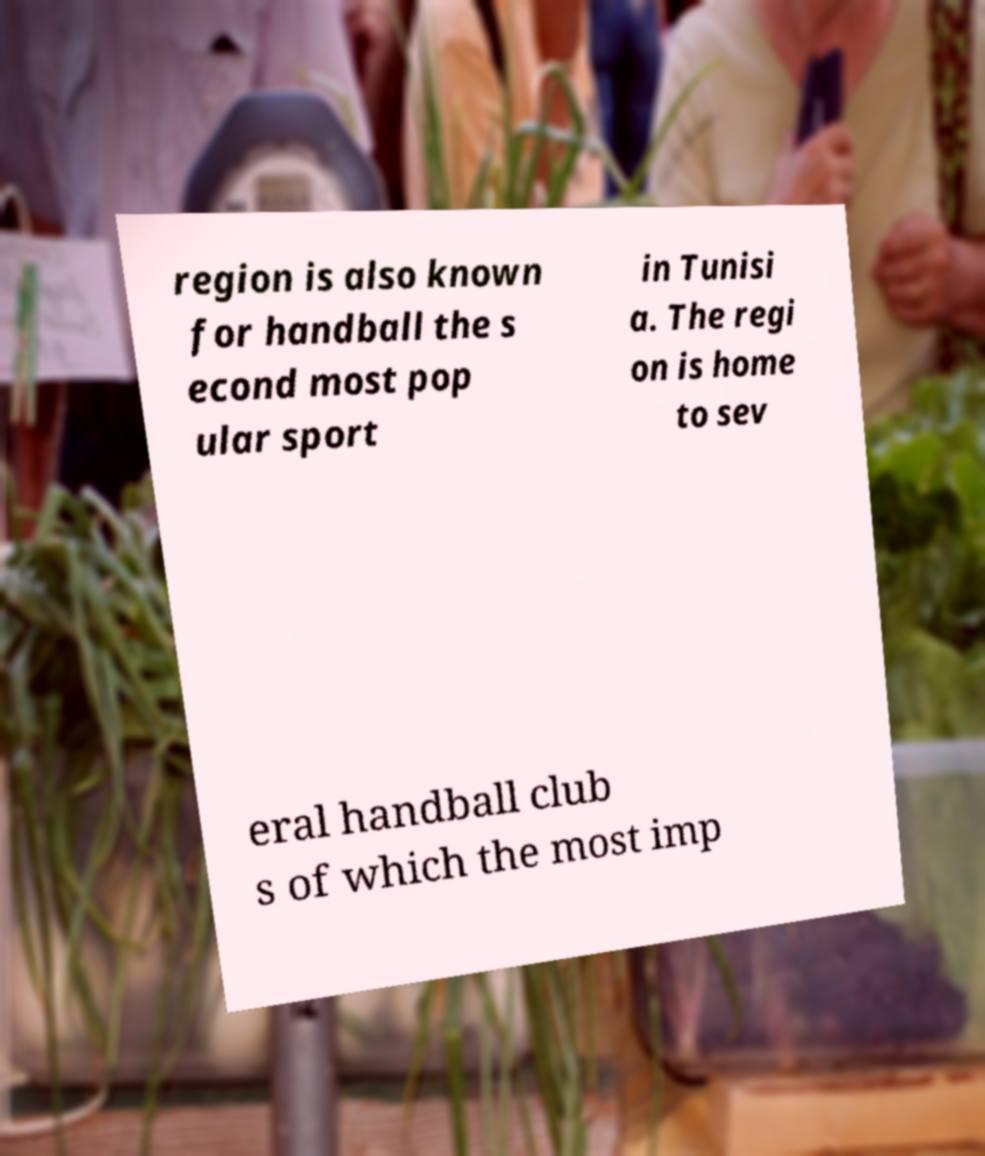For documentation purposes, I need the text within this image transcribed. Could you provide that? region is also known for handball the s econd most pop ular sport in Tunisi a. The regi on is home to sev eral handball club s of which the most imp 